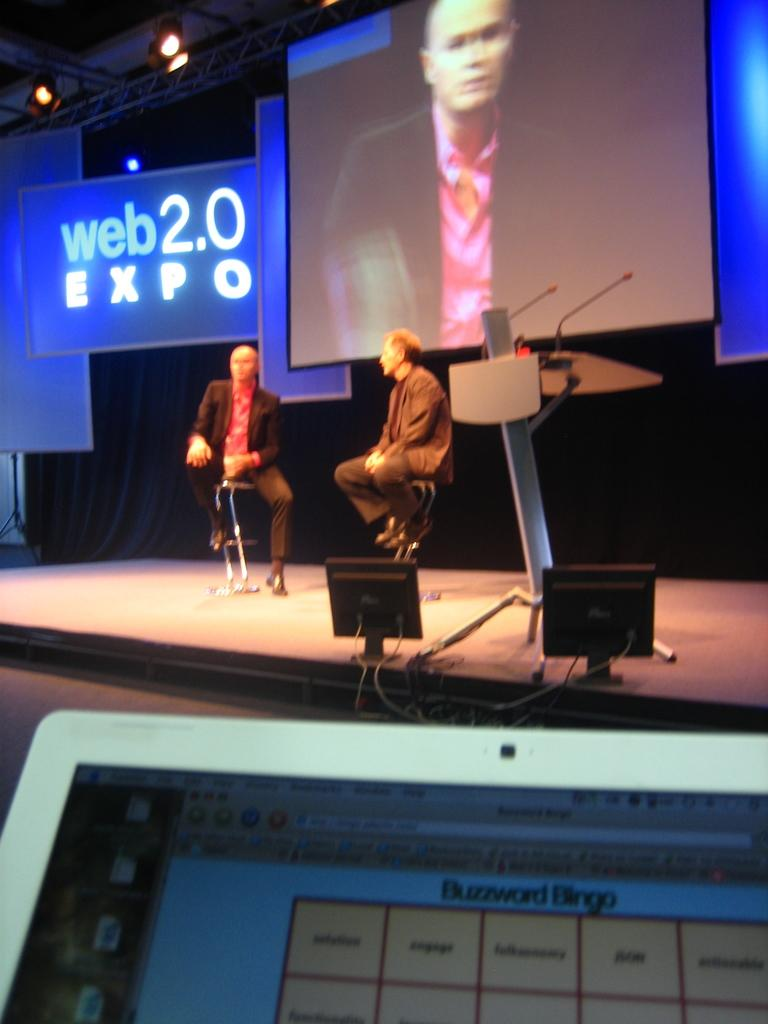<image>
Share a concise interpretation of the image provided. Two men sit on stools before a large screen and a banner with the words web2.0 Expo on it. 